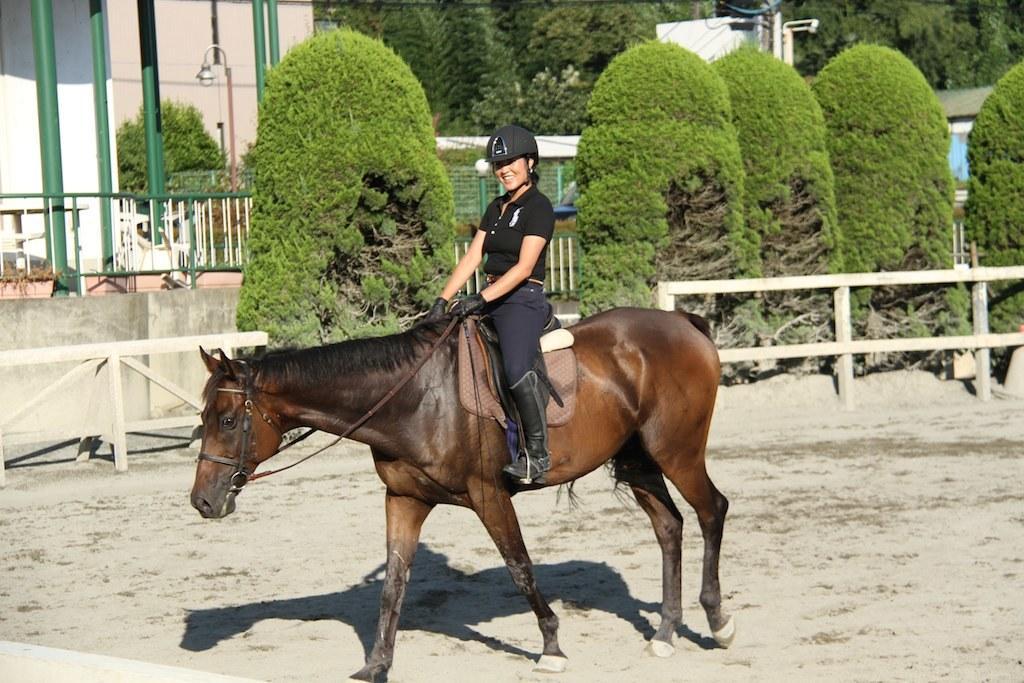In one or two sentences, can you explain what this image depicts? In this image we can see a woman sitting on the horse. In the background there are buildings, street pole, street light, trees and a pole. 